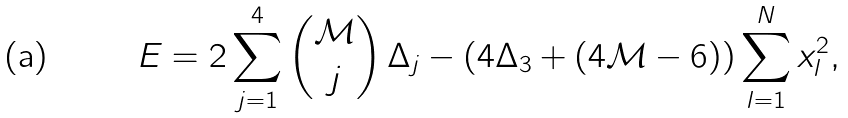<formula> <loc_0><loc_0><loc_500><loc_500>E = 2 \sum _ { j = 1 } ^ { 4 } { { \mathcal { M } } \choose j } \, \Delta _ { j } - \left ( 4 \Delta _ { 3 } + ( 4 { \mathcal { M } } - 6 ) \right ) \sum _ { l = 1 } ^ { N } x _ { l } ^ { 2 } ,</formula> 